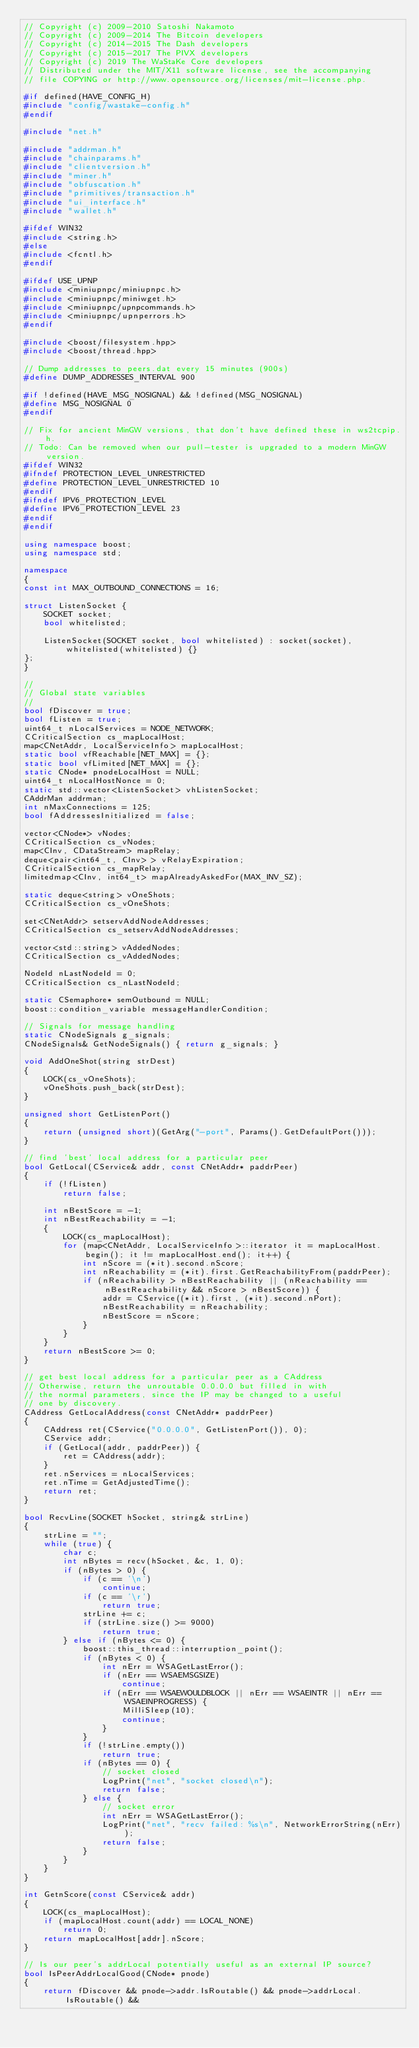Convert code to text. <code><loc_0><loc_0><loc_500><loc_500><_C++_>// Copyright (c) 2009-2010 Satoshi Nakamoto
// Copyright (c) 2009-2014 The Bitcoin developers
// Copyright (c) 2014-2015 The Dash developers
// Copyright (c) 2015-2017 The PIVX developers
// Copyright (c) 2019 The WaStaKe Core developers
// Distributed under the MIT/X11 software license, see the accompanying
// file COPYING or http://www.opensource.org/licenses/mit-license.php.

#if defined(HAVE_CONFIG_H)
#include "config/wastake-config.h"
#endif

#include "net.h"

#include "addrman.h"
#include "chainparams.h"
#include "clientversion.h"
#include "miner.h"
#include "obfuscation.h"
#include "primitives/transaction.h"
#include "ui_interface.h"
#include "wallet.h"

#ifdef WIN32
#include <string.h>
#else
#include <fcntl.h>
#endif

#ifdef USE_UPNP
#include <miniupnpc/miniupnpc.h>
#include <miniupnpc/miniwget.h>
#include <miniupnpc/upnpcommands.h>
#include <miniupnpc/upnperrors.h>
#endif

#include <boost/filesystem.hpp>
#include <boost/thread.hpp>

// Dump addresses to peers.dat every 15 minutes (900s)
#define DUMP_ADDRESSES_INTERVAL 900

#if !defined(HAVE_MSG_NOSIGNAL) && !defined(MSG_NOSIGNAL)
#define MSG_NOSIGNAL 0
#endif

// Fix for ancient MinGW versions, that don't have defined these in ws2tcpip.h.
// Todo: Can be removed when our pull-tester is upgraded to a modern MinGW version.
#ifdef WIN32
#ifndef PROTECTION_LEVEL_UNRESTRICTED
#define PROTECTION_LEVEL_UNRESTRICTED 10
#endif
#ifndef IPV6_PROTECTION_LEVEL
#define IPV6_PROTECTION_LEVEL 23
#endif
#endif

using namespace boost;
using namespace std;

namespace
{
const int MAX_OUTBOUND_CONNECTIONS = 16;

struct ListenSocket {
    SOCKET socket;
    bool whitelisted;

    ListenSocket(SOCKET socket, bool whitelisted) : socket(socket), whitelisted(whitelisted) {}
};
}

//
// Global state variables
//
bool fDiscover = true;
bool fListen = true;
uint64_t nLocalServices = NODE_NETWORK;
CCriticalSection cs_mapLocalHost;
map<CNetAddr, LocalServiceInfo> mapLocalHost;
static bool vfReachable[NET_MAX] = {};
static bool vfLimited[NET_MAX] = {};
static CNode* pnodeLocalHost = NULL;
uint64_t nLocalHostNonce = 0;
static std::vector<ListenSocket> vhListenSocket;
CAddrMan addrman;
int nMaxConnections = 125;
bool fAddressesInitialized = false;

vector<CNode*> vNodes;
CCriticalSection cs_vNodes;
map<CInv, CDataStream> mapRelay;
deque<pair<int64_t, CInv> > vRelayExpiration;
CCriticalSection cs_mapRelay;
limitedmap<CInv, int64_t> mapAlreadyAskedFor(MAX_INV_SZ);

static deque<string> vOneShots;
CCriticalSection cs_vOneShots;

set<CNetAddr> setservAddNodeAddresses;
CCriticalSection cs_setservAddNodeAddresses;

vector<std::string> vAddedNodes;
CCriticalSection cs_vAddedNodes;

NodeId nLastNodeId = 0;
CCriticalSection cs_nLastNodeId;

static CSemaphore* semOutbound = NULL;
boost::condition_variable messageHandlerCondition;

// Signals for message handling
static CNodeSignals g_signals;
CNodeSignals& GetNodeSignals() { return g_signals; }

void AddOneShot(string strDest)
{
    LOCK(cs_vOneShots);
    vOneShots.push_back(strDest);
}

unsigned short GetListenPort()
{
    return (unsigned short)(GetArg("-port", Params().GetDefaultPort()));
}

// find 'best' local address for a particular peer
bool GetLocal(CService& addr, const CNetAddr* paddrPeer)
{
    if (!fListen)
        return false;

    int nBestScore = -1;
    int nBestReachability = -1;
    {
        LOCK(cs_mapLocalHost);
        for (map<CNetAddr, LocalServiceInfo>::iterator it = mapLocalHost.begin(); it != mapLocalHost.end(); it++) {
            int nScore = (*it).second.nScore;
            int nReachability = (*it).first.GetReachabilityFrom(paddrPeer);
            if (nReachability > nBestReachability || (nReachability == nBestReachability && nScore > nBestScore)) {
                addr = CService((*it).first, (*it).second.nPort);
                nBestReachability = nReachability;
                nBestScore = nScore;
            }
        }
    }
    return nBestScore >= 0;
}

// get best local address for a particular peer as a CAddress
// Otherwise, return the unroutable 0.0.0.0 but filled in with
// the normal parameters, since the IP may be changed to a useful
// one by discovery.
CAddress GetLocalAddress(const CNetAddr* paddrPeer)
{
    CAddress ret(CService("0.0.0.0", GetListenPort()), 0);
    CService addr;
    if (GetLocal(addr, paddrPeer)) {
        ret = CAddress(addr);
    }
    ret.nServices = nLocalServices;
    ret.nTime = GetAdjustedTime();
    return ret;
}

bool RecvLine(SOCKET hSocket, string& strLine)
{
    strLine = "";
    while (true) {
        char c;
        int nBytes = recv(hSocket, &c, 1, 0);
        if (nBytes > 0) {
            if (c == '\n')
                continue;
            if (c == '\r')
                return true;
            strLine += c;
            if (strLine.size() >= 9000)
                return true;
        } else if (nBytes <= 0) {
            boost::this_thread::interruption_point();
            if (nBytes < 0) {
                int nErr = WSAGetLastError();
                if (nErr == WSAEMSGSIZE)
                    continue;
                if (nErr == WSAEWOULDBLOCK || nErr == WSAEINTR || nErr == WSAEINPROGRESS) {
                    MilliSleep(10);
                    continue;
                }
            }
            if (!strLine.empty())
                return true;
            if (nBytes == 0) {
                // socket closed
                LogPrint("net", "socket closed\n");
                return false;
            } else {
                // socket error
                int nErr = WSAGetLastError();
                LogPrint("net", "recv failed: %s\n", NetworkErrorString(nErr));
                return false;
            }
        }
    }
}

int GetnScore(const CService& addr)
{
    LOCK(cs_mapLocalHost);
    if (mapLocalHost.count(addr) == LOCAL_NONE)
        return 0;
    return mapLocalHost[addr].nScore;
}

// Is our peer's addrLocal potentially useful as an external IP source?
bool IsPeerAddrLocalGood(CNode* pnode)
{
    return fDiscover && pnode->addr.IsRoutable() && pnode->addrLocal.IsRoutable() &&</code> 